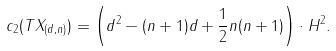<formula> <loc_0><loc_0><loc_500><loc_500>c _ { 2 } ( T X _ { ( d , n ) } ) = \left ( d ^ { 2 } - ( n + 1 ) d + \frac { 1 } { 2 } n ( n + 1 ) \right ) \cdot H ^ { 2 } .</formula> 